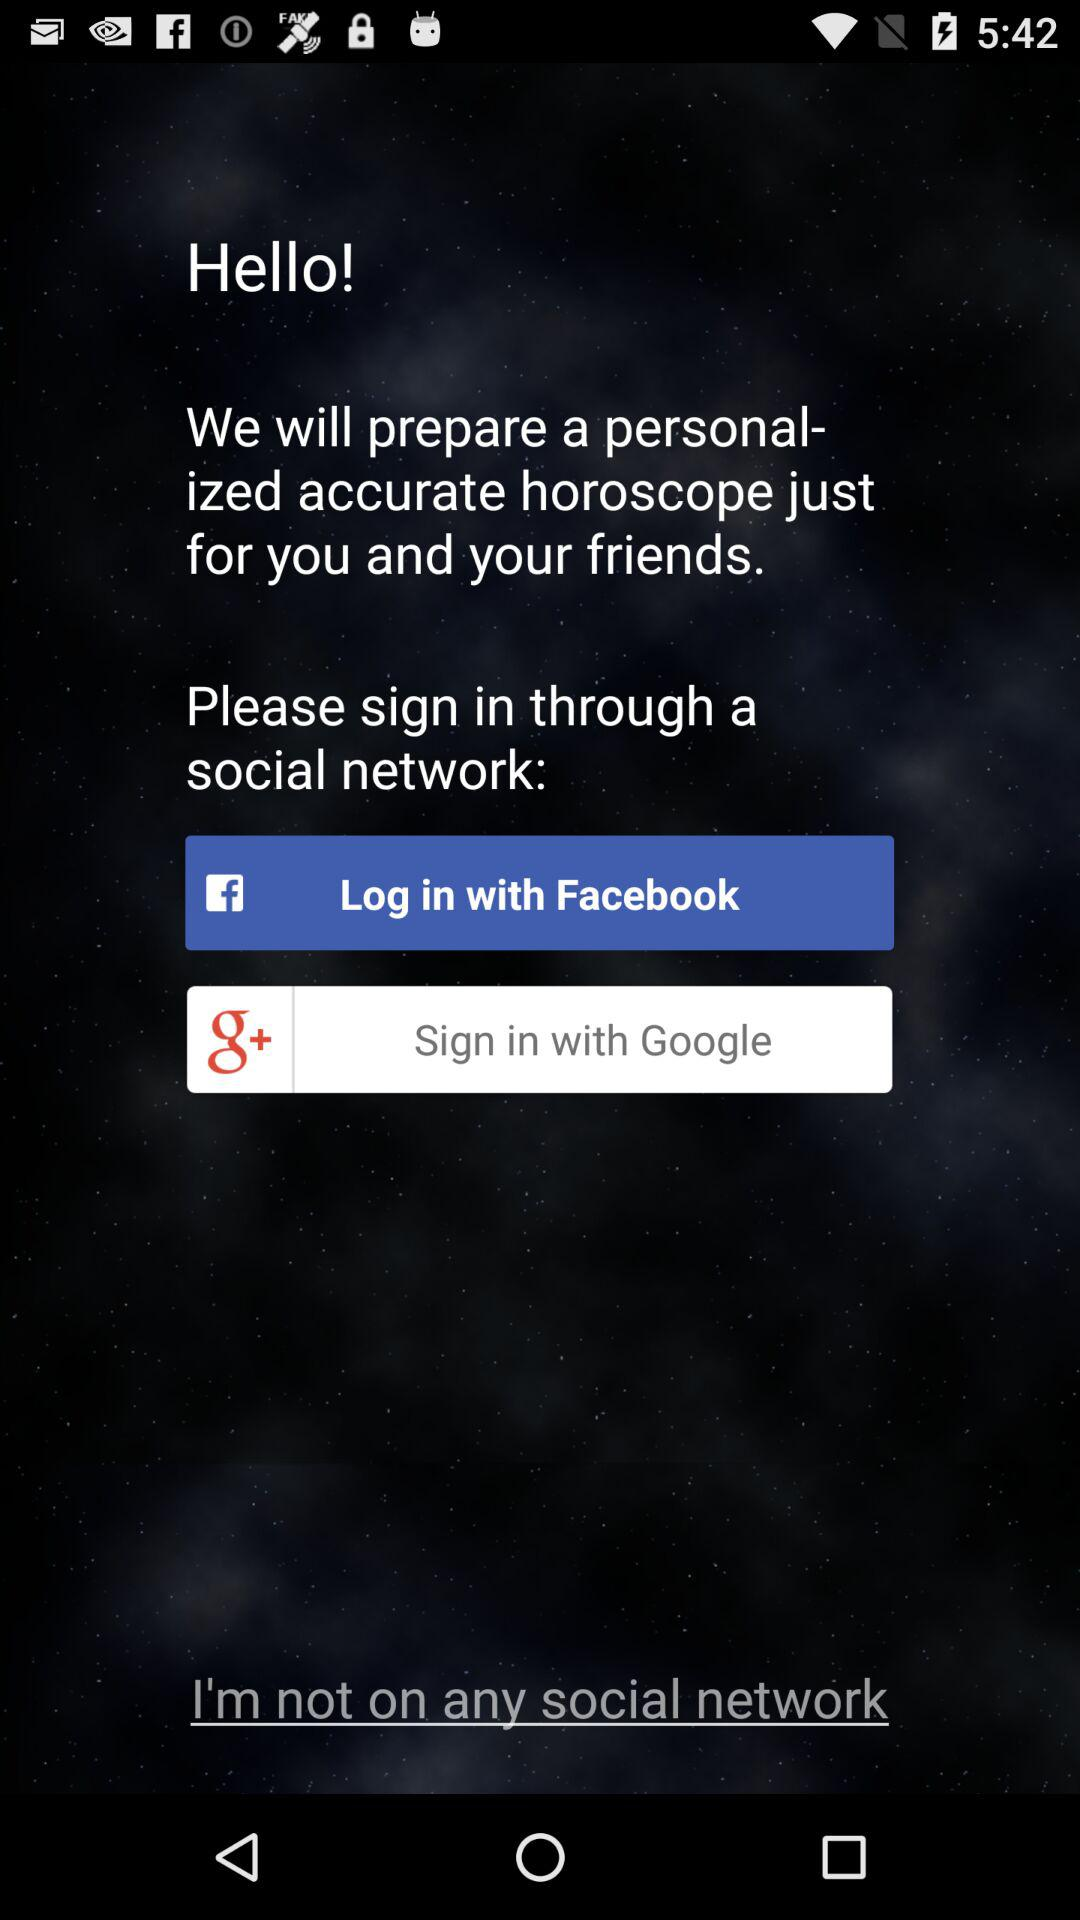What account can I use to log in? We can login through "Facebook". 